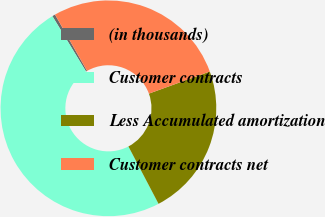Convert chart. <chart><loc_0><loc_0><loc_500><loc_500><pie_chart><fcel>(in thousands)<fcel>Customer contracts<fcel>Less Accumulated amortization<fcel>Customer contracts net<nl><fcel>0.45%<fcel>49.0%<fcel>22.85%<fcel>27.7%<nl></chart> 